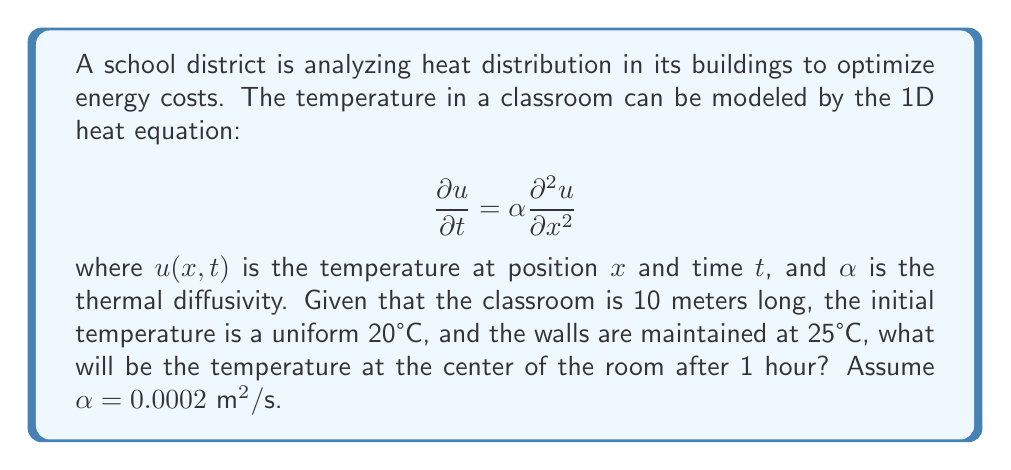Can you answer this question? To solve this problem, we need to use the solution to the 1D heat equation with Dirichlet boundary conditions. The solution is given by:

$$u(x,t) = 25 - \sum_{n=1}^{\infty} \frac{4(25-20)}{\pi(2n-1)} \sin\left(\frac{(2n-1)\pi x}{L}\right) e^{-\alpha\left(\frac{(2n-1)\pi}{L}\right)^2 t}$$

where $L$ is the length of the room.

Let's break down the solution step-by-step:

1) We have $L = 10$ m, $\alpha = 0.0002 \text{ m}^2/\text{s}$, and $t = 1 \text{ hour} = 3600 \text{ s}$.

2) The center of the room is at $x = 5$ m.

3) Substituting these values into the equation:

   $$u(5,3600) = 25 - \sum_{n=1}^{\infty} \frac{4(25-20)}{\pi(2n-1)} \sin\left(\frac{(2n-1)\pi 5}{10}\right) e^{-0.0002\left(\frac{(2n-1)\pi}{10}\right)^2 3600}$$

4) Simplify:

   $$u(5,3600) = 25 - \sum_{n=1}^{\infty} \frac{20}{\pi(2n-1)} \sin\left(\frac{(2n-1)\pi}{2}\right) e^{-0.0072(2n-1)^2}$$

5) Note that $\sin\left(\frac{(2n-1)\pi}{2}\right) = (-1)^{n+1}$

6) Therefore:

   $$u(5,3600) = 25 + \sum_{n=1}^{\infty} \frac{20(-1)^n}{\pi(2n-1)} e^{-0.0072(2n-1)^2}$$

7) We can approximate this sum by taking the first few terms. The exponential term decreases rapidly, so we'll use the first 5 terms:

   $$u(5,3600) \approx 25 + \frac{20}{\pi}\left(\frac{e^{-0.0072}}{1} - \frac{e^{-0.0648}}{3} + \frac{e^{-0.1800}}{5} - \frac{e^{-0.3528}}{7} + \frac{e^{-0.5832}}{9}\right)$$

8) Calculating this gives us approximately 24.37°C.
Answer: 24.37°C 